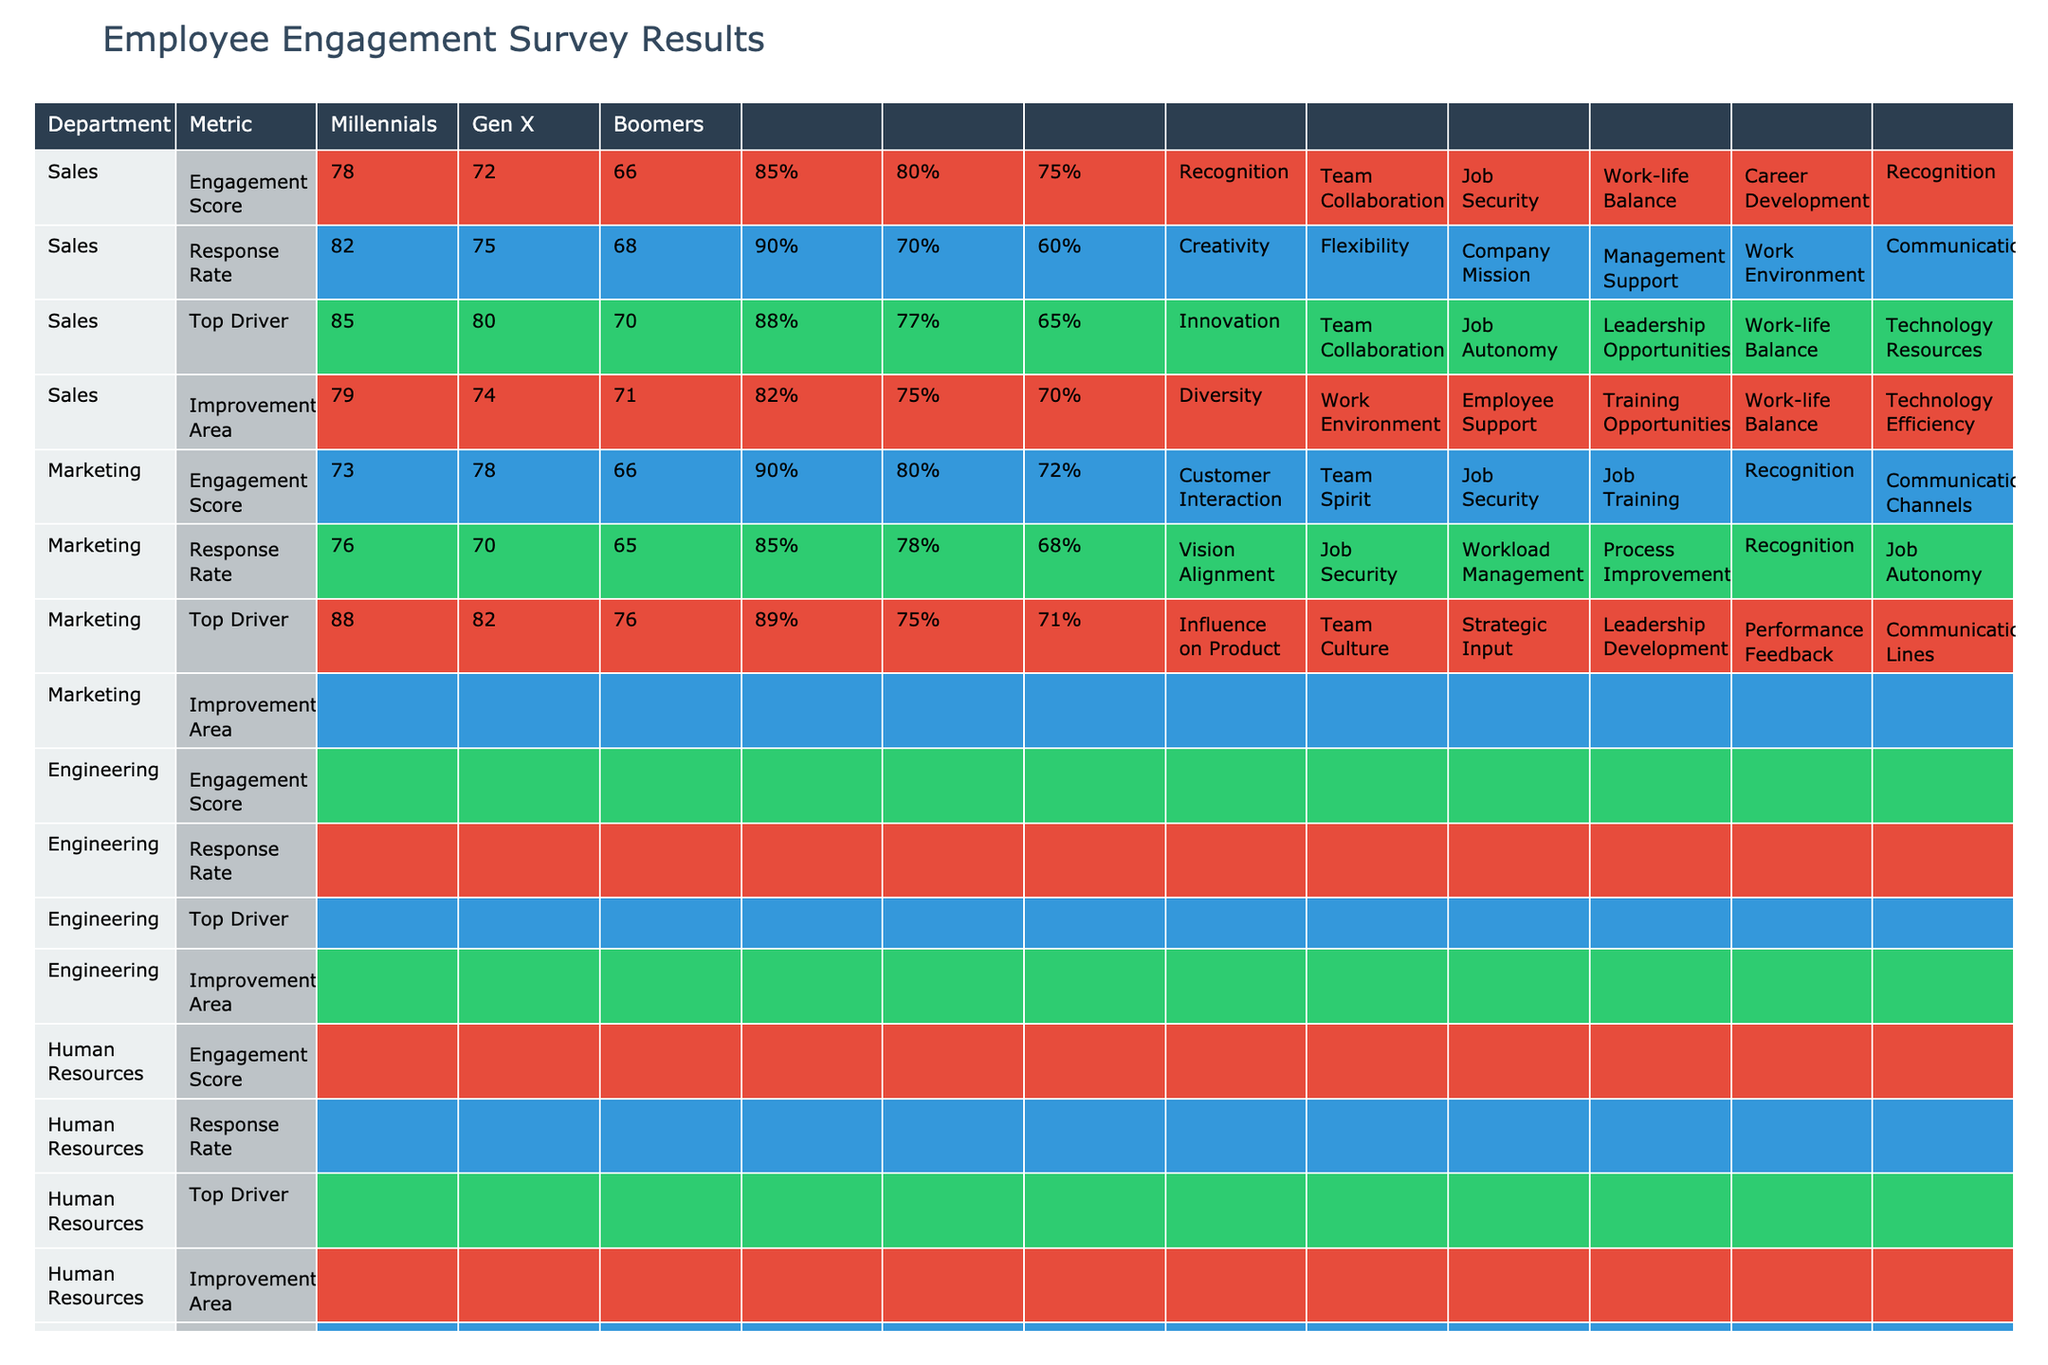What is the employee engagement score for the Engineering department among Boomers? In the table, the employee engagement score for the Engineering department under the Boomers demographic group is listed as 70.
Answer: 70 Which demographic group in Customer Service has the highest engagement score? The table shows that Millennials in Customer Service have an engagement score of 73, Gen X has 78, and Boomers have 66. The highest score is 78 for Gen X.
Answer: Gen X What is the response rate for Marketing Boomers? The table indicates that the response rate for Marketing Boomers is 60%.
Answer: 60% Which department has the lowest engagement score among Millennials? Looking at the table, the engagement scores for Millennials are: Sales (78), Marketing (82), Engineering (85), Human Resources (79), Customer Service (73), Finance (76), and Product Management (88). The lowest score is 73 in Customer Service.
Answer: Customer Service Is the top engagement driver for Finance Millennials the same as for Gen X? The top engagement driver for Finance Millennials is Vision Alignment, while for Gen X, it is Job Security. Since they are different, the answer is no.
Answer: No What is the average engagement score for all departments among Boomers? The engagement scores for Boomers by department are: Sales (66), Marketing (68), Engineering (70), Human Resources (71), Customer Service (66), Finance (65), and Product Management (76). Summing these gives 66 + 68 + 70 + 71 + 66 + 65 + 76 = 482. There are 7 departments, so the average is 482 / 7 = approximately 68.857.
Answer: 68.857 What improvement area is common for both Sales and Marketing among Gen X? The table shows that for Sales Gen X, the improvement area is Career Development, while for Marketing Gen X, it is Work Environment. Since these are different, there is no common improvement area.
Answer: No Which department has the highest response rate among Millennials, and what is that rate? Upon examining the table, the response rates for Millennials by department are: Sales (85%), Marketing (90%), Engineering (88%), Human Resources (82%), Customer Service (90%), Finance (85%), and Product Management (89%). The highest response rate is 90%, occurring in both Marketing and Customer Service.
Answer: Marketing and Customer Service, 90% What percentage of Millennials in Human Resources feel that Diversity is the top engagement driver? The table states that the top engagement driver for Millennials in Human Resources is indeed Diversity, so the answer is directly related to their presence in the table.
Answer: 79% 